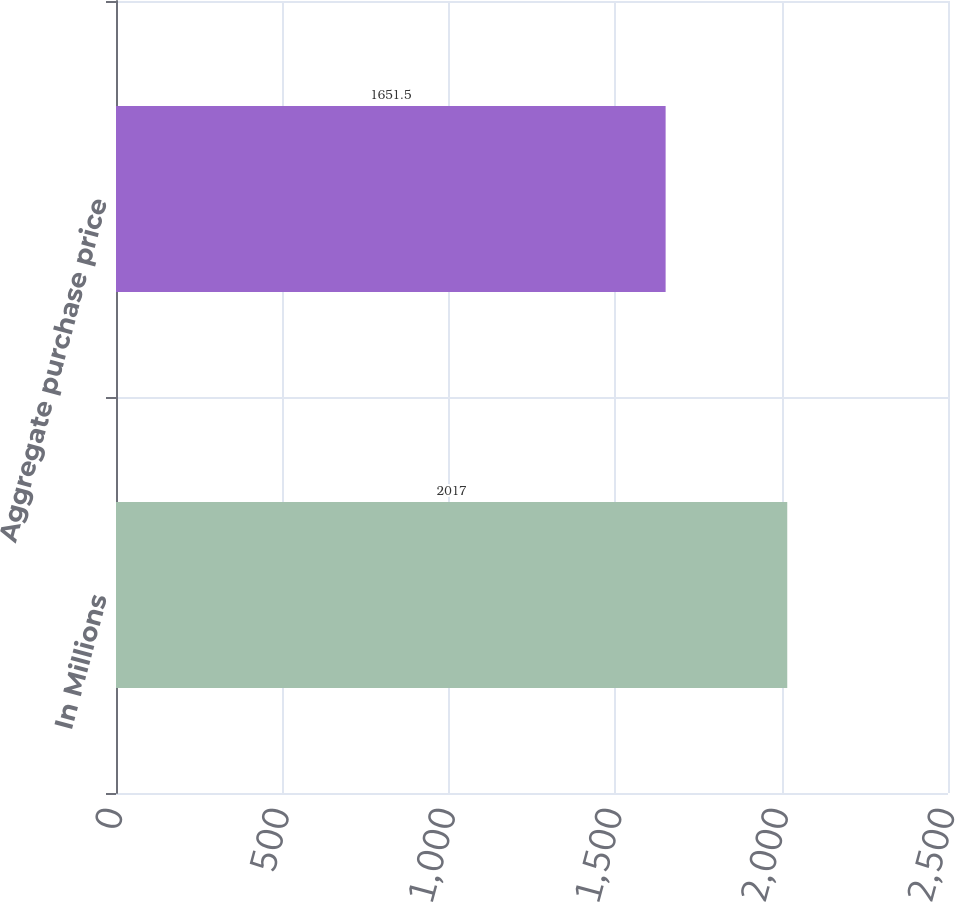Convert chart. <chart><loc_0><loc_0><loc_500><loc_500><bar_chart><fcel>In Millions<fcel>Aggregate purchase price<nl><fcel>2017<fcel>1651.5<nl></chart> 